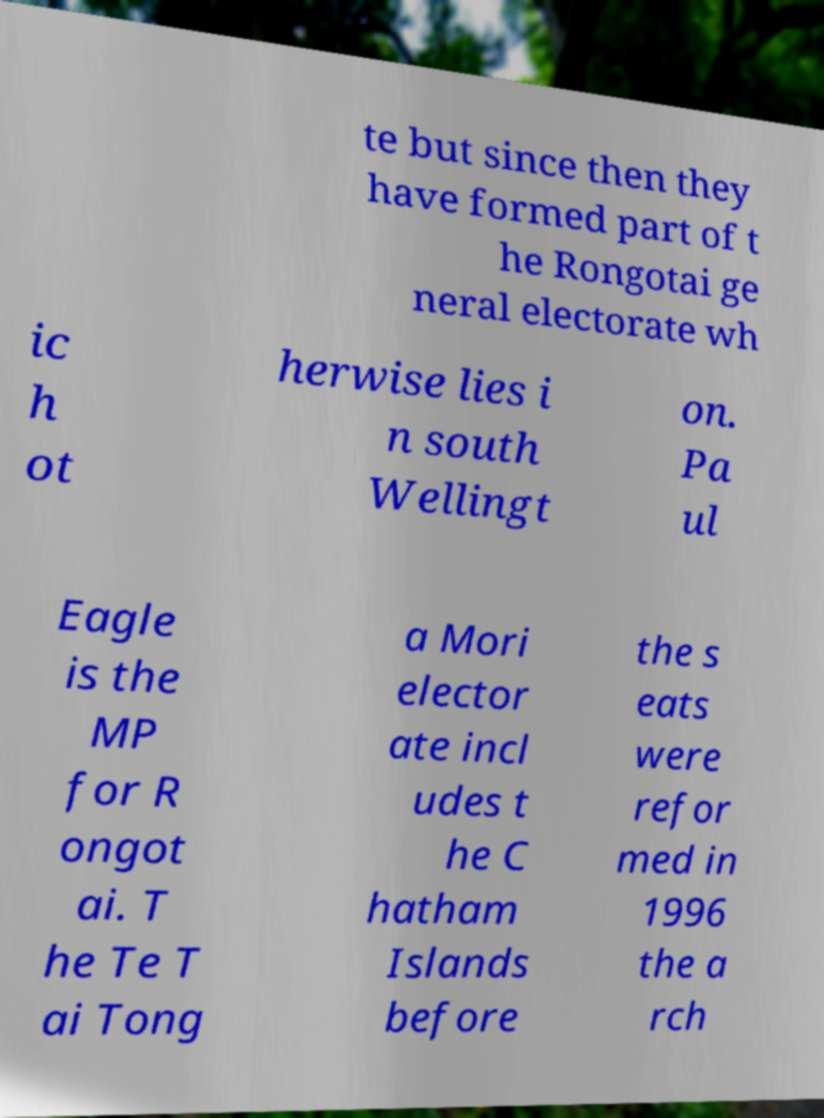Could you assist in decoding the text presented in this image and type it out clearly? te but since then they have formed part of t he Rongotai ge neral electorate wh ic h ot herwise lies i n south Wellingt on. Pa ul Eagle is the MP for R ongot ai. T he Te T ai Tong a Mori elector ate incl udes t he C hatham Islands before the s eats were refor med in 1996 the a rch 